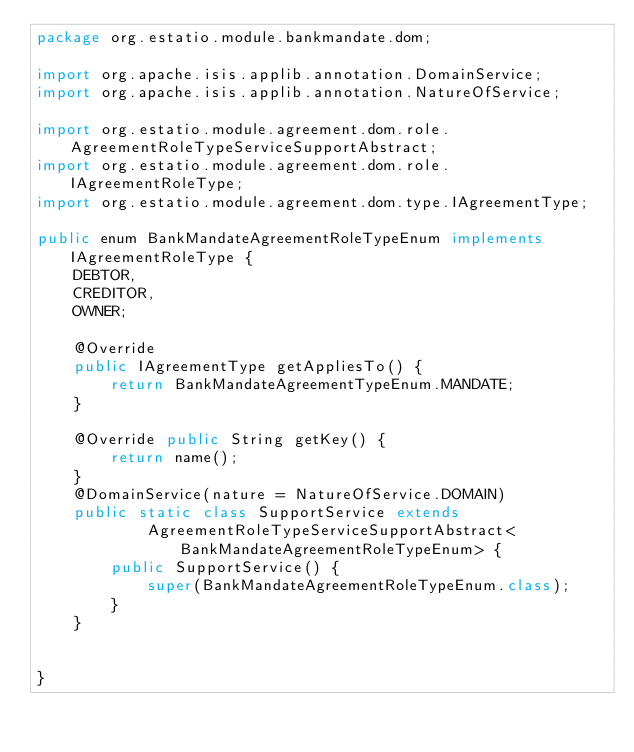<code> <loc_0><loc_0><loc_500><loc_500><_Java_>package org.estatio.module.bankmandate.dom;

import org.apache.isis.applib.annotation.DomainService;
import org.apache.isis.applib.annotation.NatureOfService;

import org.estatio.module.agreement.dom.role.AgreementRoleTypeServiceSupportAbstract;
import org.estatio.module.agreement.dom.role.IAgreementRoleType;
import org.estatio.module.agreement.dom.type.IAgreementType;

public enum BankMandateAgreementRoleTypeEnum implements IAgreementRoleType {
    DEBTOR,
    CREDITOR,
    OWNER;

    @Override
    public IAgreementType getAppliesTo() {
        return BankMandateAgreementTypeEnum.MANDATE;
    }

    @Override public String getKey() {
        return name();
    }
    @DomainService(nature = NatureOfService.DOMAIN)
    public static class SupportService extends
            AgreementRoleTypeServiceSupportAbstract<BankMandateAgreementRoleTypeEnum> {
        public SupportService() {
            super(BankMandateAgreementRoleTypeEnum.class);
        }
    }


}
</code> 